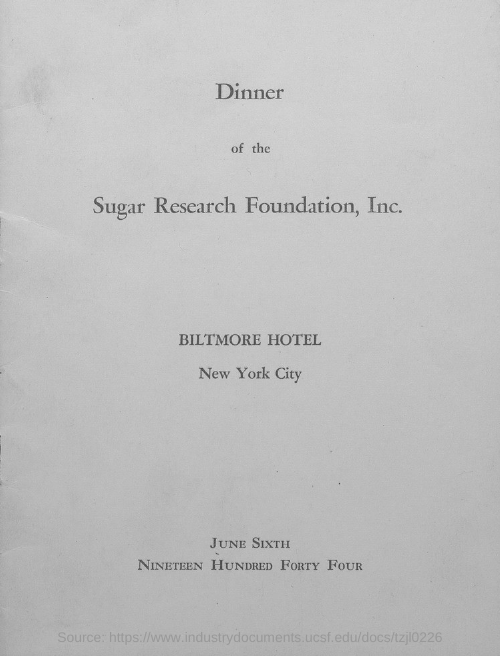Identify some key points in this picture. The dinner of the Sugar Research Foundation, Inc. was organized at the Biltmore Hotel in New York City. On June 6th, the dinner of the Sugar Research Foundation, Inc. was organized. 